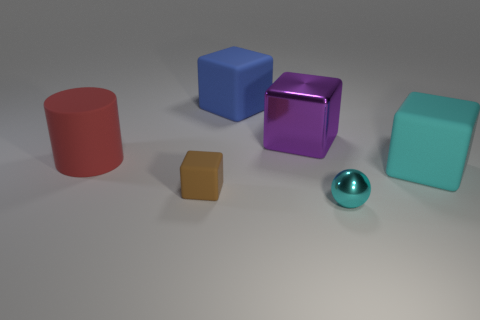Subtract all rubber blocks. How many blocks are left? 1 Subtract all blue cubes. How many cubes are left? 3 Subtract all cylinders. How many objects are left? 5 Add 1 cyan rubber objects. How many objects exist? 7 Subtract 3 blocks. How many blocks are left? 1 Add 4 large purple shiny things. How many large purple shiny things exist? 5 Subtract 1 purple cubes. How many objects are left? 5 Subtract all gray cylinders. Subtract all green balls. How many cylinders are left? 1 Subtract all purple cylinders. How many cyan cubes are left? 1 Subtract all large gray metallic cylinders. Subtract all big cyan rubber cubes. How many objects are left? 5 